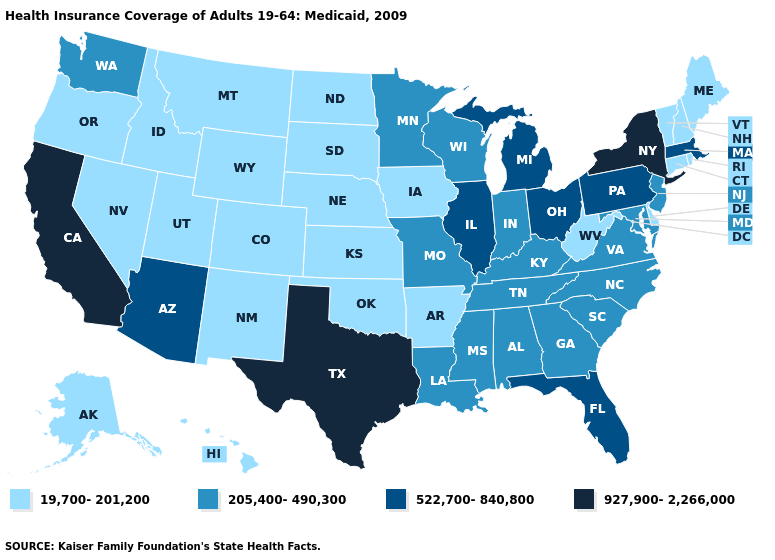What is the highest value in the South ?
Keep it brief. 927,900-2,266,000. Which states hav the highest value in the MidWest?
Give a very brief answer. Illinois, Michigan, Ohio. Does the first symbol in the legend represent the smallest category?
Short answer required. Yes. Name the states that have a value in the range 522,700-840,800?
Keep it brief. Arizona, Florida, Illinois, Massachusetts, Michigan, Ohio, Pennsylvania. What is the value of New Jersey?
Short answer required. 205,400-490,300. Name the states that have a value in the range 927,900-2,266,000?
Concise answer only. California, New York, Texas. What is the value of Georgia?
Write a very short answer. 205,400-490,300. Which states have the lowest value in the USA?
Concise answer only. Alaska, Arkansas, Colorado, Connecticut, Delaware, Hawaii, Idaho, Iowa, Kansas, Maine, Montana, Nebraska, Nevada, New Hampshire, New Mexico, North Dakota, Oklahoma, Oregon, Rhode Island, South Dakota, Utah, Vermont, West Virginia, Wyoming. Among the states that border Florida , which have the lowest value?
Concise answer only. Alabama, Georgia. What is the value of Arizona?
Give a very brief answer. 522,700-840,800. Does Utah have the lowest value in the USA?
Short answer required. Yes. Is the legend a continuous bar?
Be succinct. No. Name the states that have a value in the range 205,400-490,300?
Give a very brief answer. Alabama, Georgia, Indiana, Kentucky, Louisiana, Maryland, Minnesota, Mississippi, Missouri, New Jersey, North Carolina, South Carolina, Tennessee, Virginia, Washington, Wisconsin. What is the value of Iowa?
Short answer required. 19,700-201,200. Is the legend a continuous bar?
Answer briefly. No. 